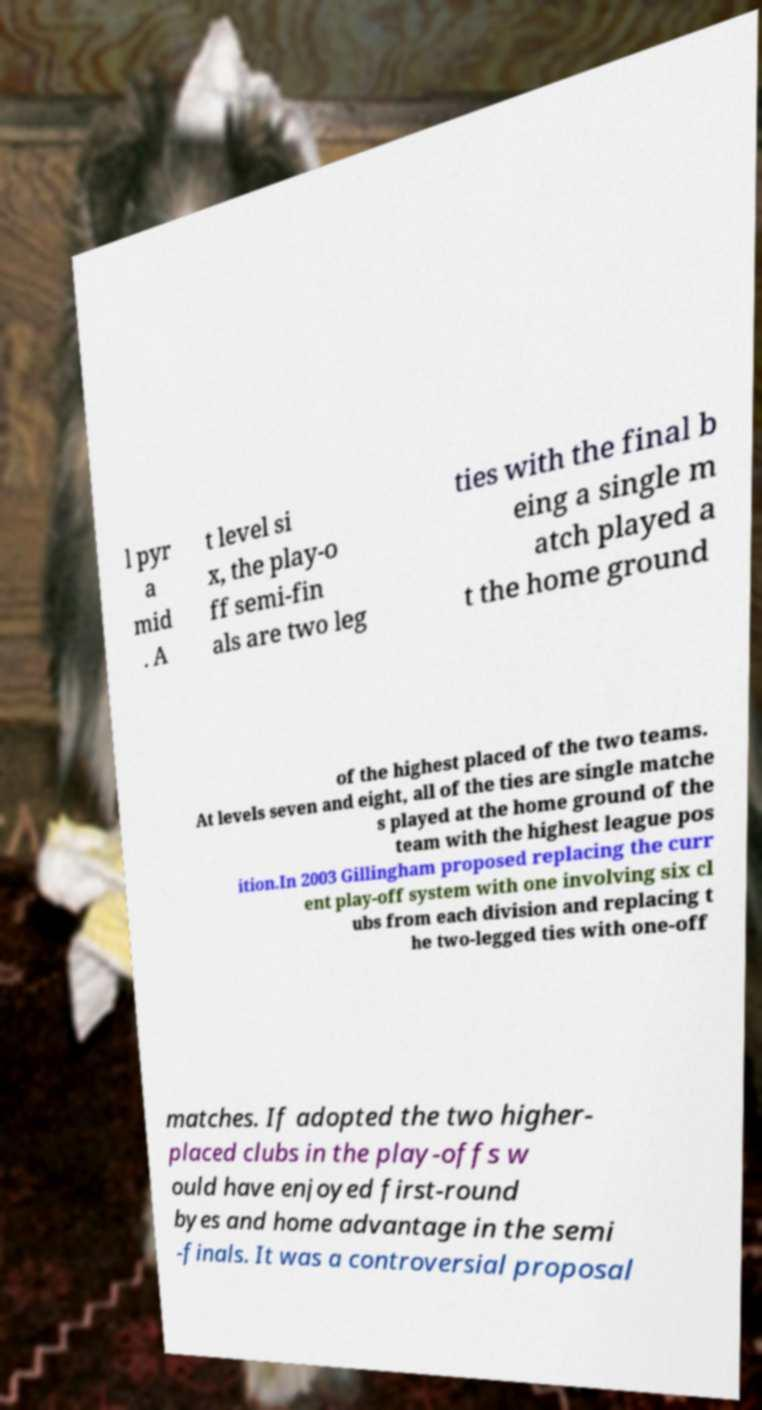What messages or text are displayed in this image? I need them in a readable, typed format. l pyr a mid . A t level si x, the play-o ff semi-fin als are two leg ties with the final b eing a single m atch played a t the home ground of the highest placed of the two teams. At levels seven and eight, all of the ties are single matche s played at the home ground of the team with the highest league pos ition.In 2003 Gillingham proposed replacing the curr ent play-off system with one involving six cl ubs from each division and replacing t he two-legged ties with one-off matches. If adopted the two higher- placed clubs in the play-offs w ould have enjoyed first-round byes and home advantage in the semi -finals. It was a controversial proposal 